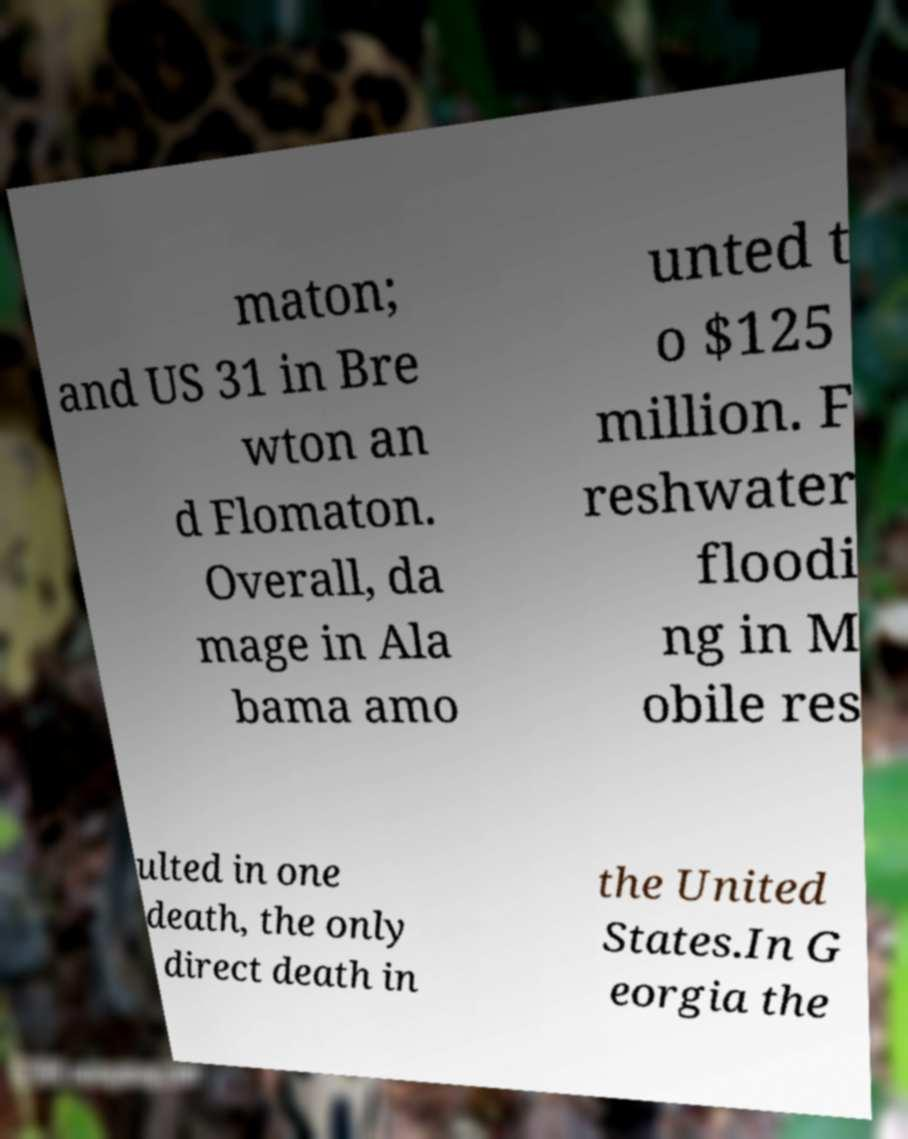Can you accurately transcribe the text from the provided image for me? maton; and US 31 in Bre wton an d Flomaton. Overall, da mage in Ala bama amo unted t o $125 million. F reshwater floodi ng in M obile res ulted in one death, the only direct death in the United States.In G eorgia the 